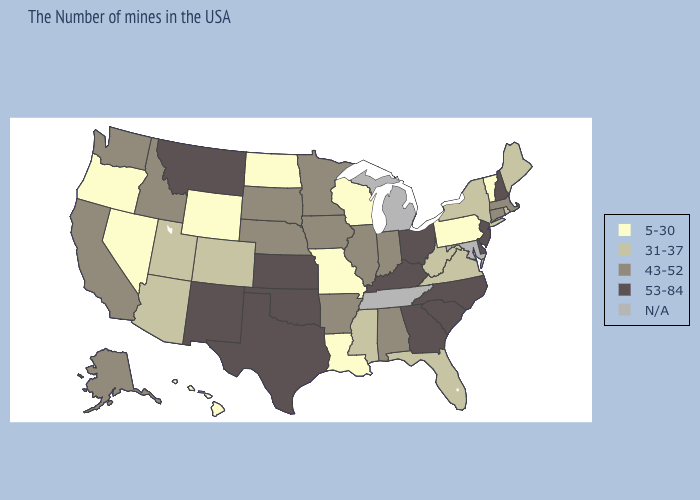Does West Virginia have the lowest value in the South?
Short answer required. No. Does the map have missing data?
Be succinct. Yes. What is the value of Vermont?
Keep it brief. 5-30. How many symbols are there in the legend?
Concise answer only. 5. Among the states that border Maryland , which have the highest value?
Write a very short answer. Delaware. What is the highest value in the USA?
Concise answer only. 53-84. What is the highest value in the USA?
Give a very brief answer. 53-84. What is the value of Maryland?
Be succinct. N/A. What is the highest value in states that border Missouri?
Answer briefly. 53-84. What is the highest value in the West ?
Be succinct. 53-84. Name the states that have a value in the range 43-52?
Concise answer only. Massachusetts, Connecticut, Indiana, Alabama, Illinois, Arkansas, Minnesota, Iowa, Nebraska, South Dakota, Idaho, California, Washington, Alaska. 